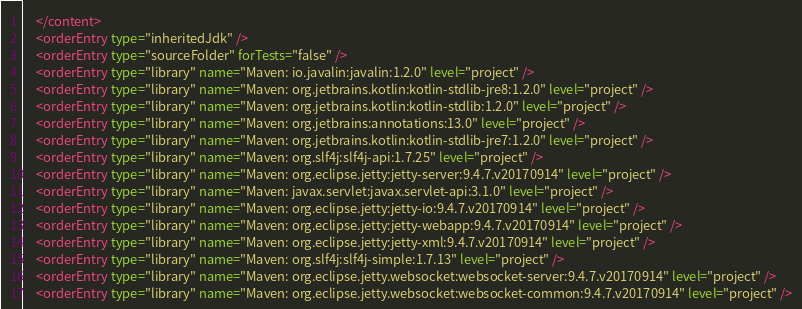<code> <loc_0><loc_0><loc_500><loc_500><_XML_>    </content>
    <orderEntry type="inheritedJdk" />
    <orderEntry type="sourceFolder" forTests="false" />
    <orderEntry type="library" name="Maven: io.javalin:javalin:1.2.0" level="project" />
    <orderEntry type="library" name="Maven: org.jetbrains.kotlin:kotlin-stdlib-jre8:1.2.0" level="project" />
    <orderEntry type="library" name="Maven: org.jetbrains.kotlin:kotlin-stdlib:1.2.0" level="project" />
    <orderEntry type="library" name="Maven: org.jetbrains:annotations:13.0" level="project" />
    <orderEntry type="library" name="Maven: org.jetbrains.kotlin:kotlin-stdlib-jre7:1.2.0" level="project" />
    <orderEntry type="library" name="Maven: org.slf4j:slf4j-api:1.7.25" level="project" />
    <orderEntry type="library" name="Maven: org.eclipse.jetty:jetty-server:9.4.7.v20170914" level="project" />
    <orderEntry type="library" name="Maven: javax.servlet:javax.servlet-api:3.1.0" level="project" />
    <orderEntry type="library" name="Maven: org.eclipse.jetty:jetty-io:9.4.7.v20170914" level="project" />
    <orderEntry type="library" name="Maven: org.eclipse.jetty:jetty-webapp:9.4.7.v20170914" level="project" />
    <orderEntry type="library" name="Maven: org.eclipse.jetty:jetty-xml:9.4.7.v20170914" level="project" />
    <orderEntry type="library" name="Maven: org.slf4j:slf4j-simple:1.7.13" level="project" />
    <orderEntry type="library" name="Maven: org.eclipse.jetty.websocket:websocket-server:9.4.7.v20170914" level="project" />
    <orderEntry type="library" name="Maven: org.eclipse.jetty.websocket:websocket-common:9.4.7.v20170914" level="project" /></code> 